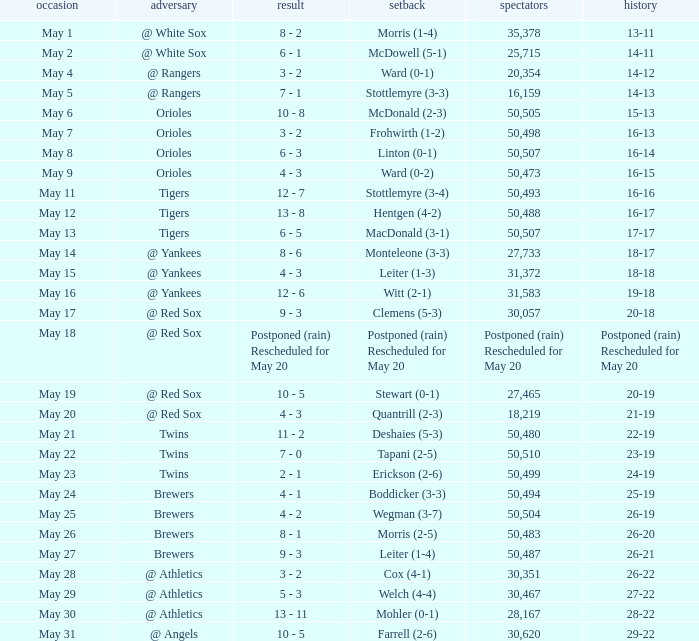On what date was their record 26-19? May 25. 